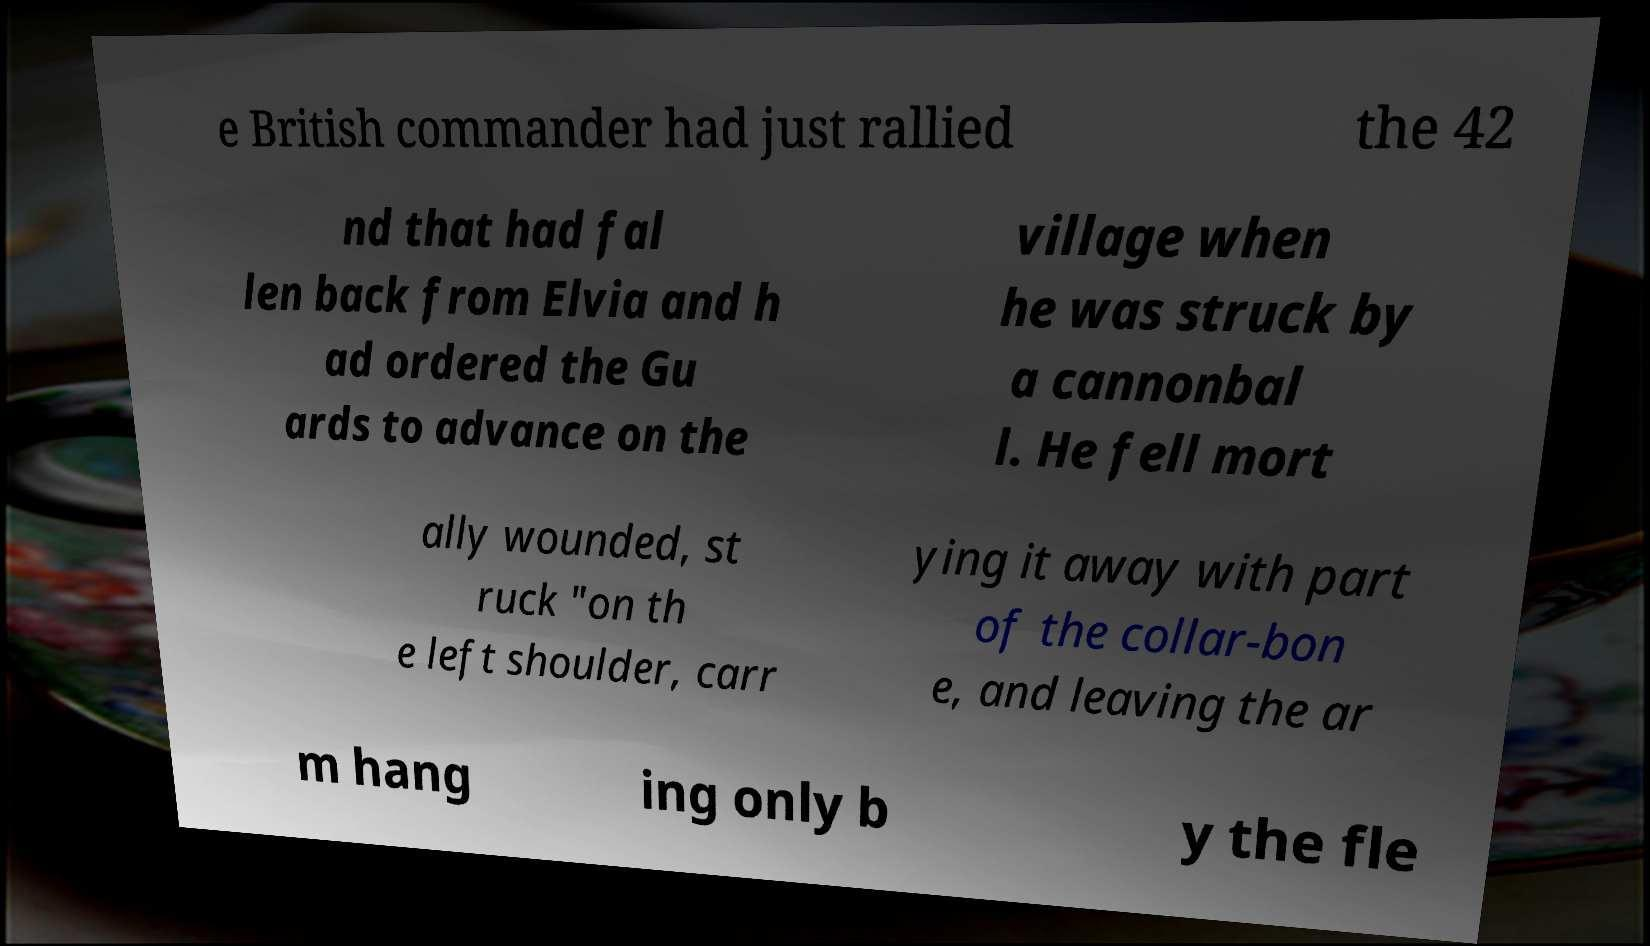Can you read and provide the text displayed in the image?This photo seems to have some interesting text. Can you extract and type it out for me? e British commander had just rallied the 42 nd that had fal len back from Elvia and h ad ordered the Gu ards to advance on the village when he was struck by a cannonbal l. He fell mort ally wounded, st ruck "on th e left shoulder, carr ying it away with part of the collar-bon e, and leaving the ar m hang ing only b y the fle 